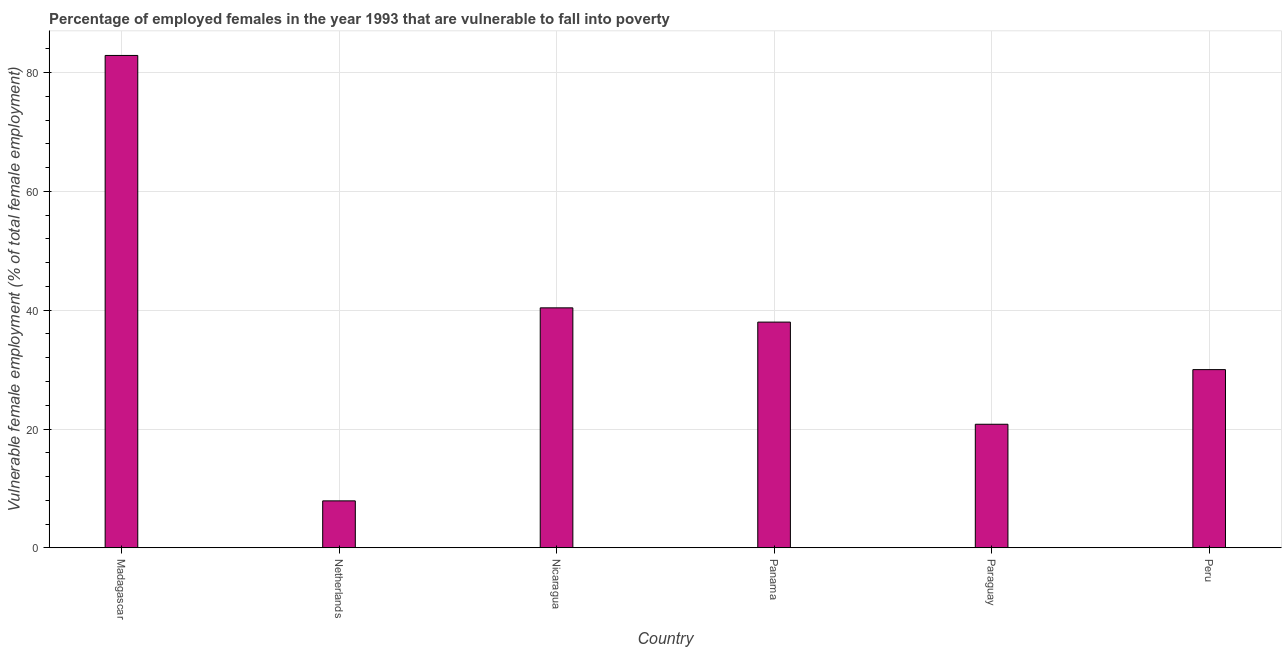What is the title of the graph?
Provide a short and direct response. Percentage of employed females in the year 1993 that are vulnerable to fall into poverty. What is the label or title of the Y-axis?
Ensure brevity in your answer.  Vulnerable female employment (% of total female employment). What is the percentage of employed females who are vulnerable to fall into poverty in Netherlands?
Offer a terse response. 7.9. Across all countries, what is the maximum percentage of employed females who are vulnerable to fall into poverty?
Keep it short and to the point. 82.9. Across all countries, what is the minimum percentage of employed females who are vulnerable to fall into poverty?
Offer a terse response. 7.9. In which country was the percentage of employed females who are vulnerable to fall into poverty maximum?
Make the answer very short. Madagascar. In which country was the percentage of employed females who are vulnerable to fall into poverty minimum?
Your answer should be compact. Netherlands. What is the sum of the percentage of employed females who are vulnerable to fall into poverty?
Offer a very short reply. 220. What is the difference between the percentage of employed females who are vulnerable to fall into poverty in Nicaragua and Peru?
Your response must be concise. 10.4. What is the average percentage of employed females who are vulnerable to fall into poverty per country?
Your answer should be very brief. 36.67. In how many countries, is the percentage of employed females who are vulnerable to fall into poverty greater than 72 %?
Your answer should be compact. 1. What is the ratio of the percentage of employed females who are vulnerable to fall into poverty in Madagascar to that in Peru?
Give a very brief answer. 2.76. Is the difference between the percentage of employed females who are vulnerable to fall into poverty in Madagascar and Netherlands greater than the difference between any two countries?
Your response must be concise. Yes. What is the difference between the highest and the second highest percentage of employed females who are vulnerable to fall into poverty?
Provide a succinct answer. 42.5. What is the difference between the highest and the lowest percentage of employed females who are vulnerable to fall into poverty?
Offer a very short reply. 75. How many countries are there in the graph?
Make the answer very short. 6. Are the values on the major ticks of Y-axis written in scientific E-notation?
Keep it short and to the point. No. What is the Vulnerable female employment (% of total female employment) in Madagascar?
Make the answer very short. 82.9. What is the Vulnerable female employment (% of total female employment) of Netherlands?
Keep it short and to the point. 7.9. What is the Vulnerable female employment (% of total female employment) of Nicaragua?
Your response must be concise. 40.4. What is the Vulnerable female employment (% of total female employment) in Paraguay?
Offer a very short reply. 20.8. What is the difference between the Vulnerable female employment (% of total female employment) in Madagascar and Nicaragua?
Offer a very short reply. 42.5. What is the difference between the Vulnerable female employment (% of total female employment) in Madagascar and Panama?
Offer a very short reply. 44.9. What is the difference between the Vulnerable female employment (% of total female employment) in Madagascar and Paraguay?
Offer a very short reply. 62.1. What is the difference between the Vulnerable female employment (% of total female employment) in Madagascar and Peru?
Your answer should be compact. 52.9. What is the difference between the Vulnerable female employment (% of total female employment) in Netherlands and Nicaragua?
Offer a very short reply. -32.5. What is the difference between the Vulnerable female employment (% of total female employment) in Netherlands and Panama?
Offer a very short reply. -30.1. What is the difference between the Vulnerable female employment (% of total female employment) in Netherlands and Peru?
Keep it short and to the point. -22.1. What is the difference between the Vulnerable female employment (% of total female employment) in Nicaragua and Panama?
Offer a very short reply. 2.4. What is the difference between the Vulnerable female employment (% of total female employment) in Nicaragua and Paraguay?
Ensure brevity in your answer.  19.6. What is the difference between the Vulnerable female employment (% of total female employment) in Nicaragua and Peru?
Your response must be concise. 10.4. What is the difference between the Vulnerable female employment (% of total female employment) in Panama and Peru?
Your response must be concise. 8. What is the difference between the Vulnerable female employment (% of total female employment) in Paraguay and Peru?
Provide a short and direct response. -9.2. What is the ratio of the Vulnerable female employment (% of total female employment) in Madagascar to that in Netherlands?
Give a very brief answer. 10.49. What is the ratio of the Vulnerable female employment (% of total female employment) in Madagascar to that in Nicaragua?
Your response must be concise. 2.05. What is the ratio of the Vulnerable female employment (% of total female employment) in Madagascar to that in Panama?
Offer a terse response. 2.18. What is the ratio of the Vulnerable female employment (% of total female employment) in Madagascar to that in Paraguay?
Make the answer very short. 3.99. What is the ratio of the Vulnerable female employment (% of total female employment) in Madagascar to that in Peru?
Give a very brief answer. 2.76. What is the ratio of the Vulnerable female employment (% of total female employment) in Netherlands to that in Nicaragua?
Your answer should be compact. 0.2. What is the ratio of the Vulnerable female employment (% of total female employment) in Netherlands to that in Panama?
Your answer should be very brief. 0.21. What is the ratio of the Vulnerable female employment (% of total female employment) in Netherlands to that in Paraguay?
Your answer should be compact. 0.38. What is the ratio of the Vulnerable female employment (% of total female employment) in Netherlands to that in Peru?
Provide a succinct answer. 0.26. What is the ratio of the Vulnerable female employment (% of total female employment) in Nicaragua to that in Panama?
Your response must be concise. 1.06. What is the ratio of the Vulnerable female employment (% of total female employment) in Nicaragua to that in Paraguay?
Make the answer very short. 1.94. What is the ratio of the Vulnerable female employment (% of total female employment) in Nicaragua to that in Peru?
Offer a very short reply. 1.35. What is the ratio of the Vulnerable female employment (% of total female employment) in Panama to that in Paraguay?
Your answer should be compact. 1.83. What is the ratio of the Vulnerable female employment (% of total female employment) in Panama to that in Peru?
Provide a short and direct response. 1.27. What is the ratio of the Vulnerable female employment (% of total female employment) in Paraguay to that in Peru?
Ensure brevity in your answer.  0.69. 